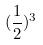<formula> <loc_0><loc_0><loc_500><loc_500>( \frac { 1 } { 2 } ) ^ { 3 }</formula> 